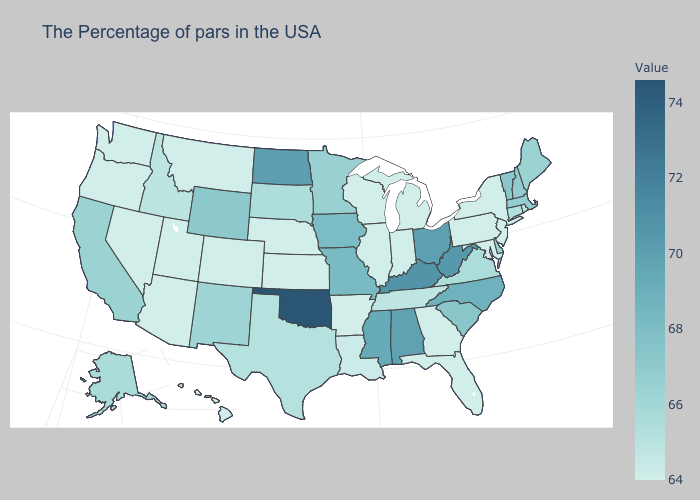Does Wyoming have the highest value in the West?
Short answer required. Yes. Does Arkansas have the lowest value in the South?
Keep it brief. Yes. Does Iowa have the lowest value in the MidWest?
Give a very brief answer. No. Does New York have the lowest value in the Northeast?
Give a very brief answer. Yes. Does the map have missing data?
Quick response, please. No. Does Tennessee have a lower value than West Virginia?
Short answer required. Yes. 